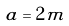<formula> <loc_0><loc_0><loc_500><loc_500>a = 2 m</formula> 